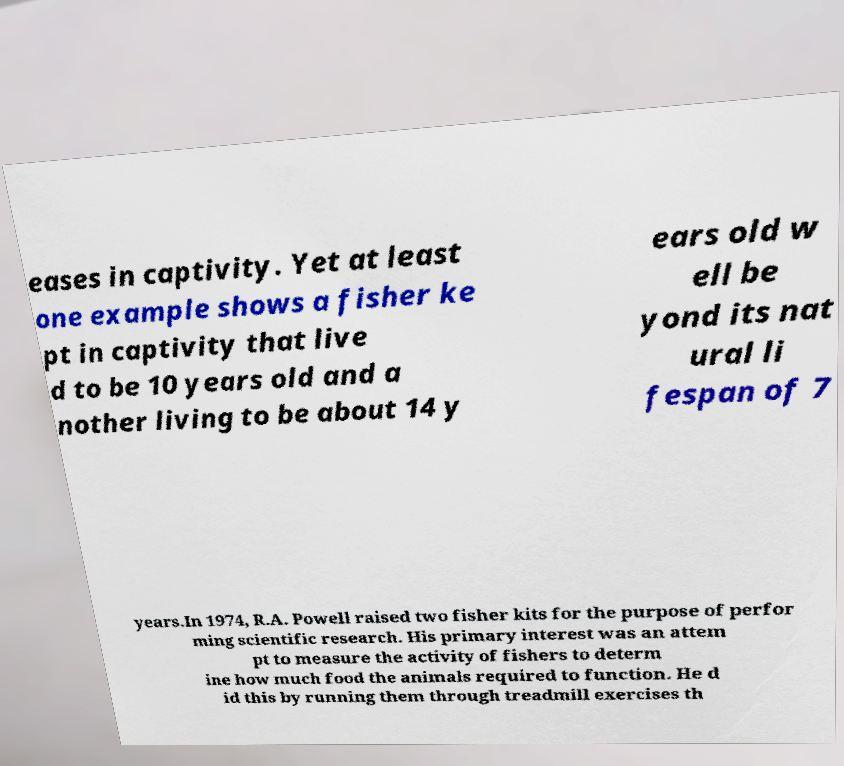Could you assist in decoding the text presented in this image and type it out clearly? eases in captivity. Yet at least one example shows a fisher ke pt in captivity that live d to be 10 years old and a nother living to be about 14 y ears old w ell be yond its nat ural li fespan of 7 years.In 1974, R.A. Powell raised two fisher kits for the purpose of perfor ming scientific research. His primary interest was an attem pt to measure the activity of fishers to determ ine how much food the animals required to function. He d id this by running them through treadmill exercises th 